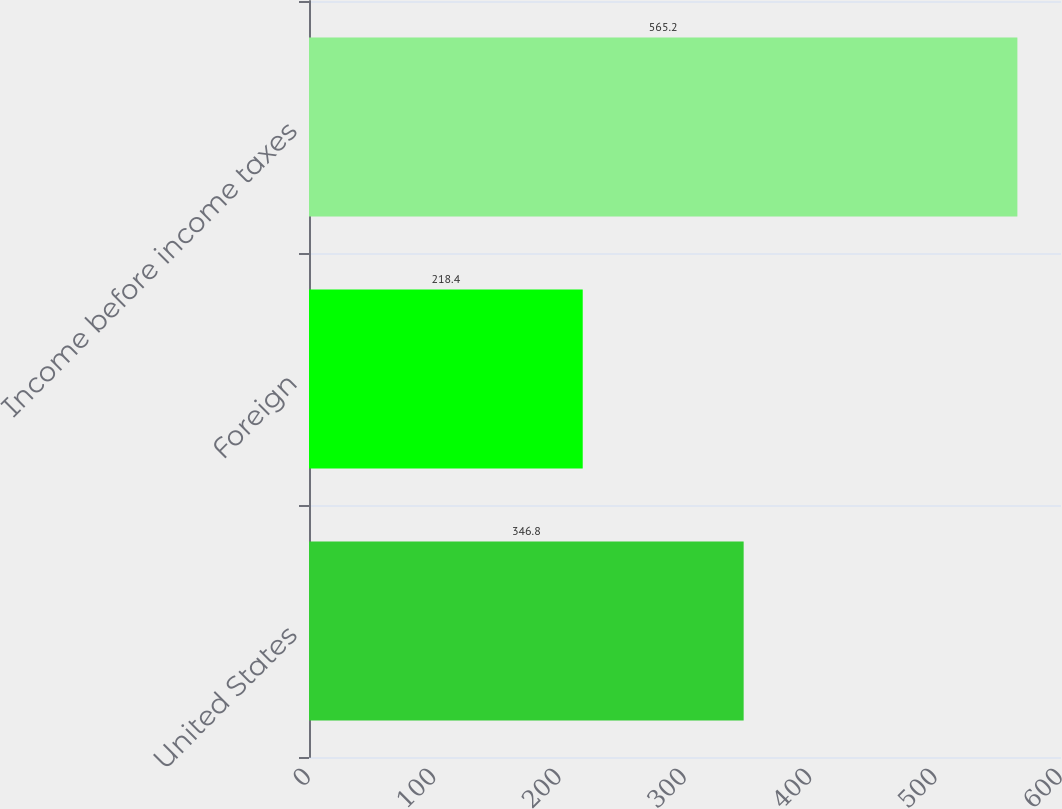<chart> <loc_0><loc_0><loc_500><loc_500><bar_chart><fcel>United States<fcel>Foreign<fcel>Income before income taxes<nl><fcel>346.8<fcel>218.4<fcel>565.2<nl></chart> 